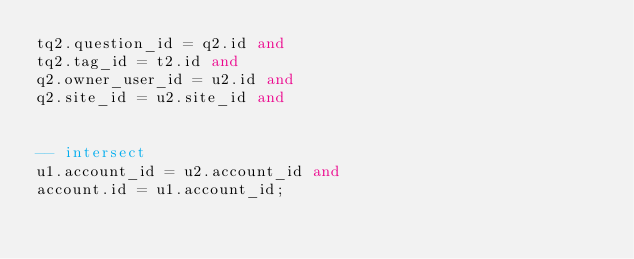<code> <loc_0><loc_0><loc_500><loc_500><_SQL_>tq2.question_id = q2.id and
tq2.tag_id = t2.id and
q2.owner_user_id = u2.id and
q2.site_id = u2.site_id and


-- intersect
u1.account_id = u2.account_id and
account.id = u1.account_id;

</code> 